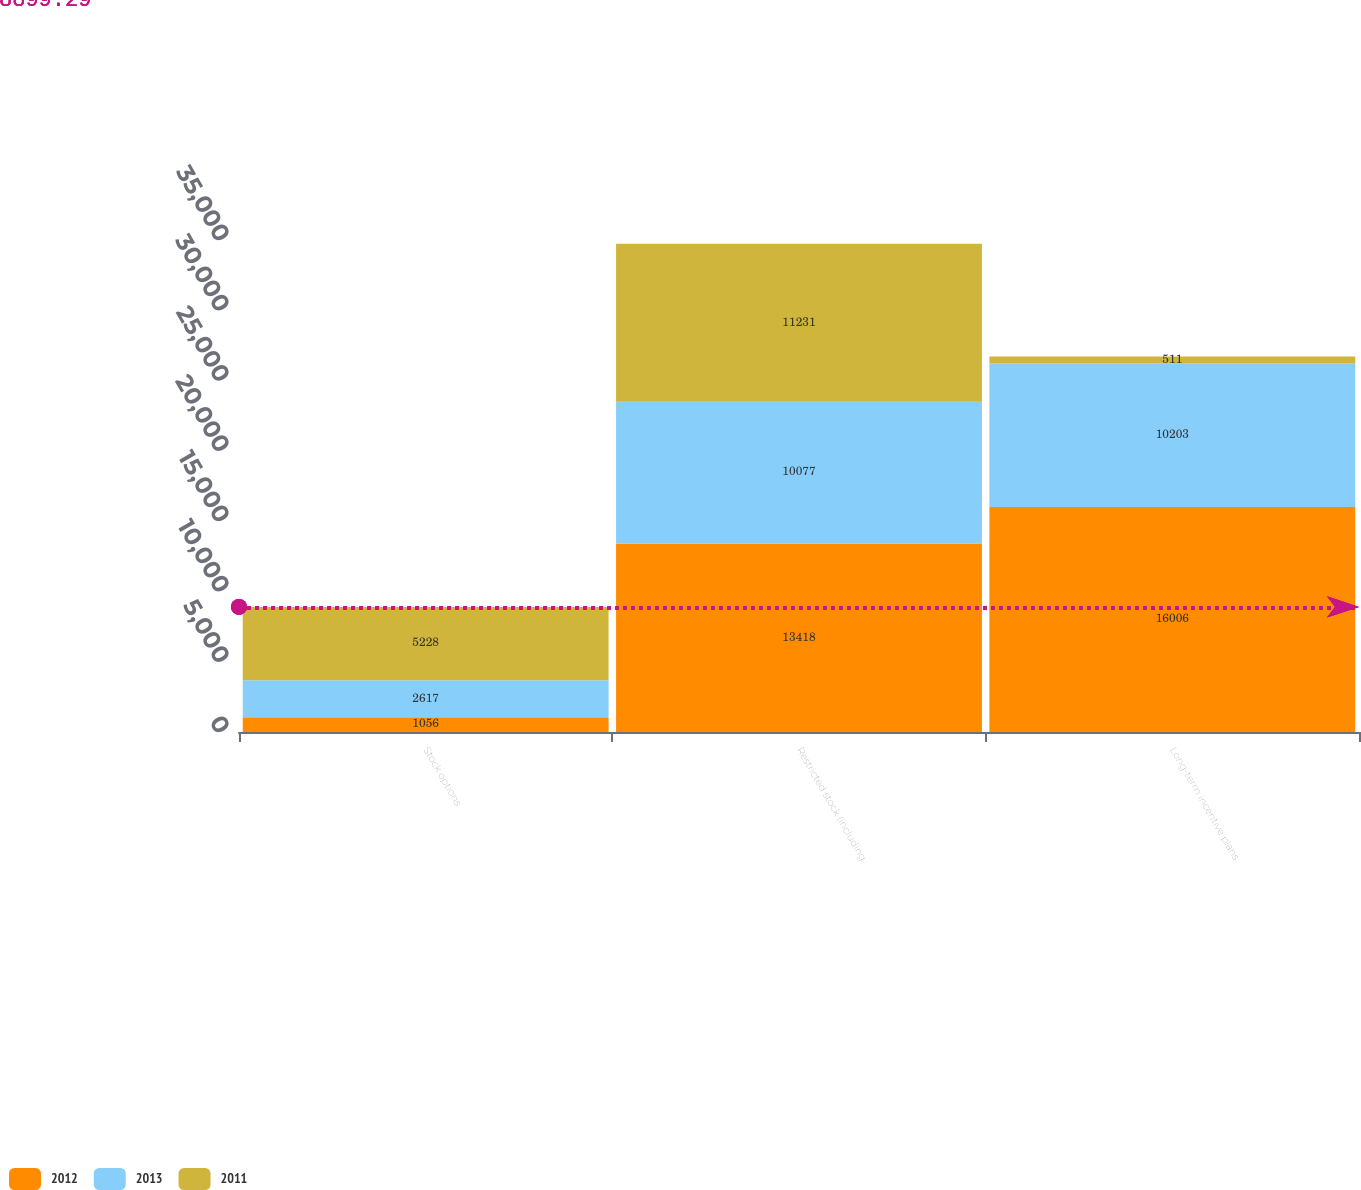Convert chart. <chart><loc_0><loc_0><loc_500><loc_500><stacked_bar_chart><ecel><fcel>Stock options<fcel>Restricted stock (including<fcel>Long-term incentive plans<nl><fcel>2012<fcel>1056<fcel>13418<fcel>16006<nl><fcel>2013<fcel>2617<fcel>10077<fcel>10203<nl><fcel>2011<fcel>5228<fcel>11231<fcel>511<nl></chart> 